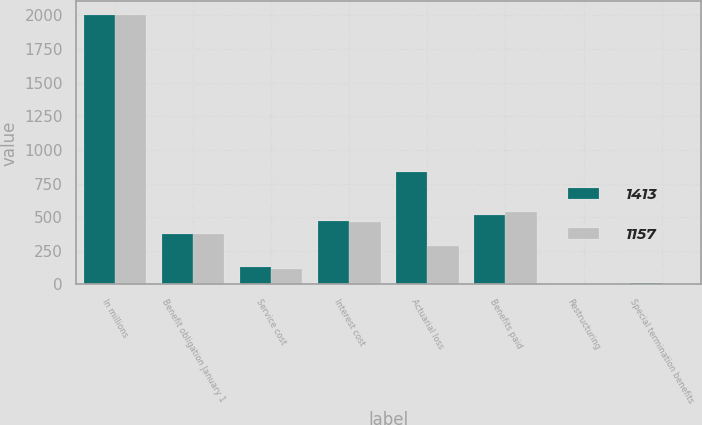Convert chart to OTSL. <chart><loc_0><loc_0><loc_500><loc_500><stacked_bar_chart><ecel><fcel>In millions<fcel>Benefit obligation January 1<fcel>Service cost<fcel>Interest cost<fcel>Actuarial loss<fcel>Benefits paid<fcel>Restructuring<fcel>Special termination benefits<nl><fcel>1413<fcel>2005<fcel>377.5<fcel>129<fcel>474<fcel>833<fcel>515<fcel>4<fcel>11<nl><fcel>1157<fcel>2004<fcel>377.5<fcel>115<fcel>467<fcel>288<fcel>537<fcel>1<fcel>1<nl></chart> 